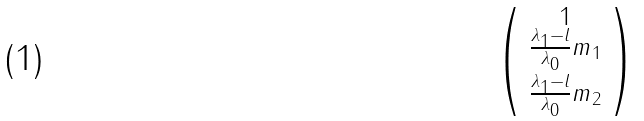<formula> <loc_0><loc_0><loc_500><loc_500>\begin{psmallmatrix} 1 \\ \frac { \lambda _ { 1 } - l } { \lambda _ { 0 } } m _ { 1 } \\ \frac { \lambda _ { 1 } - l } { \lambda _ { 0 } } m _ { 2 } \end{psmallmatrix}</formula> 